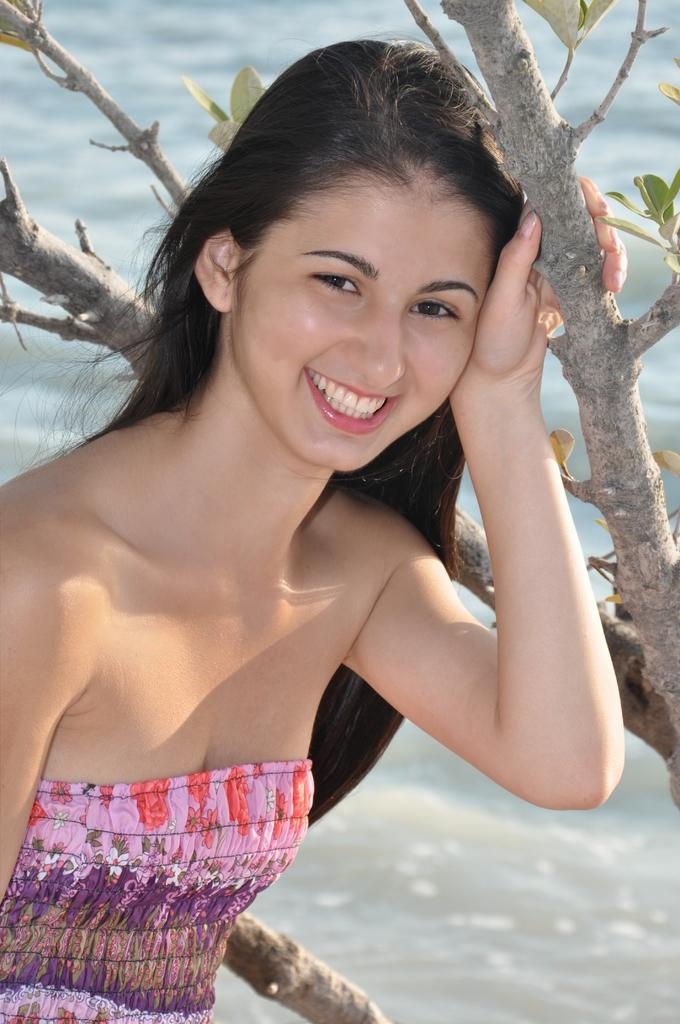Who is present in the image? There is a woman in the image. What is the woman's expression? The woman is smiling. What natural element can be seen in the image? There is a tree in the image. What else can be seen in the image besides the woman and the tree? There is water in the image. What type of building is visible in the image? There is no building present in the image. Can you describe the shape of the circle in the image? There is no circle present in the image. 